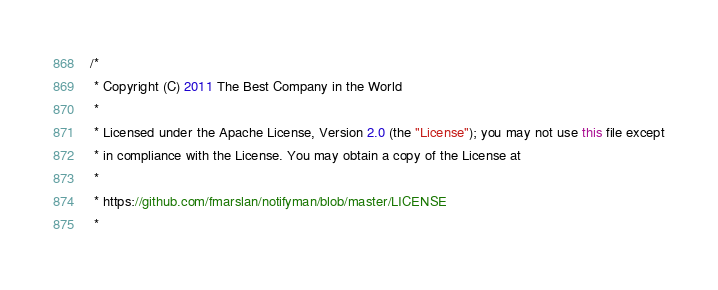Convert code to text. <code><loc_0><loc_0><loc_500><loc_500><_Java_>/*
 * Copyright (C) 2011 The Best Company in the World
 * 
 * Licensed under the Apache License, Version 2.0 (the "License"); you may not use this file except
 * in compliance with the License. You may obtain a copy of the License at
 * 
 * https://github.com/fmarslan/notifyman/blob/master/LICENSE
 * </code> 